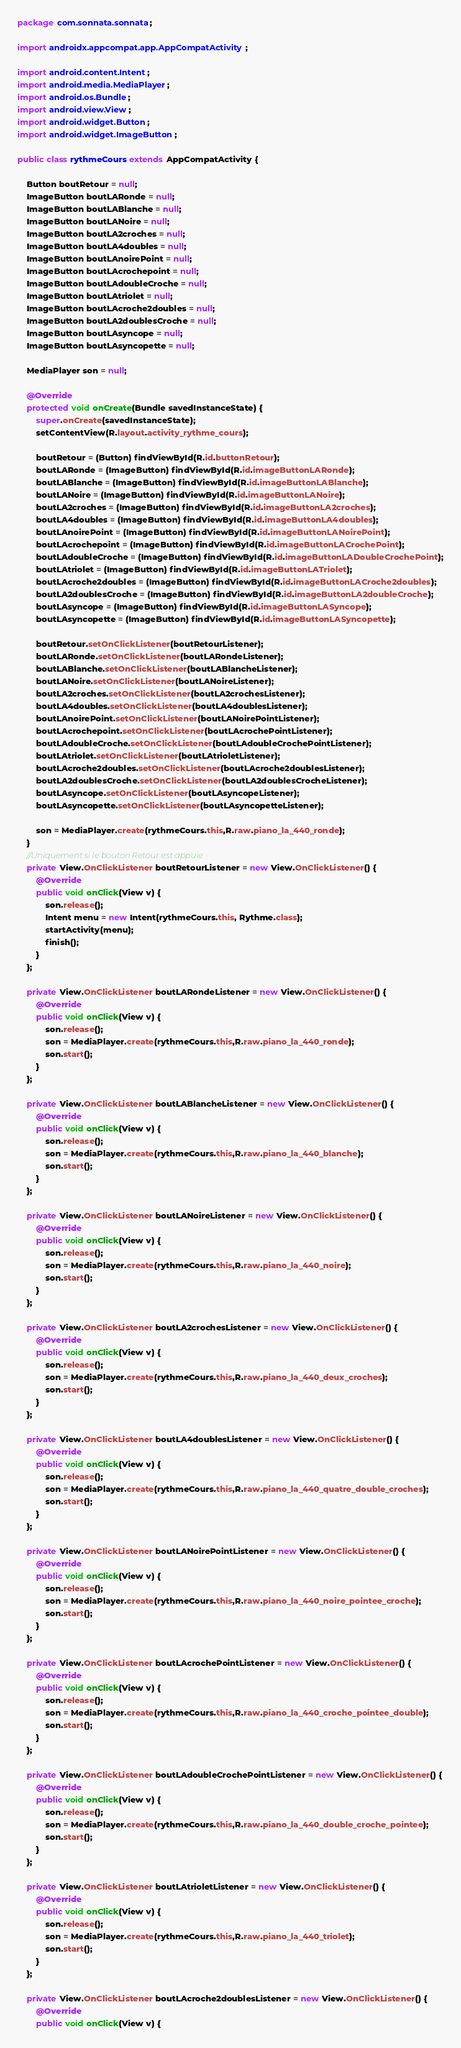<code> <loc_0><loc_0><loc_500><loc_500><_Java_>package com.sonnata.sonnata;

import androidx.appcompat.app.AppCompatActivity;

import android.content.Intent;
import android.media.MediaPlayer;
import android.os.Bundle;
import android.view.View;
import android.widget.Button;
import android.widget.ImageButton;

public class rythmeCours extends AppCompatActivity {

    Button boutRetour = null;
    ImageButton boutLARonde = null;
    ImageButton boutLABlanche = null;
    ImageButton boutLANoire = null;
    ImageButton boutLA2croches = null;
    ImageButton boutLA4doubles = null;
    ImageButton boutLAnoirePoint = null;
    ImageButton boutLAcrochepoint = null;
    ImageButton boutLAdoubleCroche = null;
    ImageButton boutLAtriolet = null;
    ImageButton boutLAcroche2doubles = null;
    ImageButton boutLA2doublesCroche = null;
    ImageButton boutLAsyncope = null;
    ImageButton boutLAsyncopette = null;

    MediaPlayer son = null;

    @Override
    protected void onCreate(Bundle savedInstanceState) {
        super.onCreate(savedInstanceState);
        setContentView(R.layout.activity_rythme_cours);

        boutRetour = (Button) findViewById(R.id.buttonRetour);
        boutLARonde = (ImageButton) findViewById(R.id.imageButtonLARonde);
        boutLABlanche = (ImageButton) findViewById(R.id.imageButtonLABlanche);
        boutLANoire = (ImageButton) findViewById(R.id.imageButtonLANoire);
        boutLA2croches = (ImageButton) findViewById(R.id.imageButtonLA2croches);
        boutLA4doubles = (ImageButton) findViewById(R.id.imageButtonLA4doubles);
        boutLAnoirePoint = (ImageButton) findViewById(R.id.imageButtonLANoirePoint);
        boutLAcrochepoint = (ImageButton) findViewById(R.id.imageButtonLACrochePoint);
        boutLAdoubleCroche = (ImageButton) findViewById(R.id.imageButtonLADoubleCrochePoint);
        boutLAtriolet = (ImageButton) findViewById(R.id.imageButtonLATriolet);
        boutLAcroche2doubles = (ImageButton) findViewById(R.id.imageButtonLACroche2doubles);
        boutLA2doublesCroche = (ImageButton) findViewById(R.id.imageButtonLA2doubleCroche);
        boutLAsyncope = (ImageButton) findViewById(R.id.imageButtonLASyncope);
        boutLAsyncopette = (ImageButton) findViewById(R.id.imageButtonLASyncopette);

        boutRetour.setOnClickListener(boutRetourListener);
        boutLARonde.setOnClickListener(boutLARondeListener);
        boutLABlanche.setOnClickListener(boutLABlancheListener);
        boutLANoire.setOnClickListener(boutLANoireListener);
        boutLA2croches.setOnClickListener(boutLA2crochesListener);
        boutLA4doubles.setOnClickListener(boutLA4doublesListener);
        boutLAnoirePoint.setOnClickListener(boutLANoirePointListener);
        boutLAcrochepoint.setOnClickListener(boutLAcrochePointListener);
        boutLAdoubleCroche.setOnClickListener(boutLAdoubleCrochePointListener);
        boutLAtriolet.setOnClickListener(boutLAtrioletListener);
        boutLAcroche2doubles.setOnClickListener(boutLAcroche2doublesListener);
        boutLA2doublesCroche.setOnClickListener(boutLA2doublesCrocheListener);
        boutLAsyncope.setOnClickListener(boutLAsyncopeListener);
        boutLAsyncopette.setOnClickListener(boutLAsyncopetteListener);

        son = MediaPlayer.create(rythmeCours.this,R.raw.piano_la_440_ronde);
    }
    //Uniquement si le bouton Retour est appuie
    private View.OnClickListener boutRetourListener = new View.OnClickListener() {
        @Override
        public void onClick(View v) {
            son.release();
            Intent menu = new Intent(rythmeCours.this, Rythme.class);
            startActivity(menu);
            finish();
        }
    };

    private View.OnClickListener boutLARondeListener = new View.OnClickListener() {
        @Override
        public void onClick(View v) {
            son.release();
            son = MediaPlayer.create(rythmeCours.this,R.raw.piano_la_440_ronde);
            son.start();
        }
    };

    private View.OnClickListener boutLABlancheListener = new View.OnClickListener() {
        @Override
        public void onClick(View v) {
            son.release();
            son = MediaPlayer.create(rythmeCours.this,R.raw.piano_la_440_blanche);
            son.start();
        }
    };

    private View.OnClickListener boutLANoireListener = new View.OnClickListener() {
        @Override
        public void onClick(View v) {
            son.release();
            son = MediaPlayer.create(rythmeCours.this,R.raw.piano_la_440_noire);
            son.start();
        }
    };

    private View.OnClickListener boutLA2crochesListener = new View.OnClickListener() {
        @Override
        public void onClick(View v) {
            son.release();
            son = MediaPlayer.create(rythmeCours.this,R.raw.piano_la_440_deux_croches);
            son.start();
        }
    };

    private View.OnClickListener boutLA4doublesListener = new View.OnClickListener() {
        @Override
        public void onClick(View v) {
            son.release();
            son = MediaPlayer.create(rythmeCours.this,R.raw.piano_la_440_quatre_double_croches);
            son.start();
        }
    };

    private View.OnClickListener boutLANoirePointListener = new View.OnClickListener() {
        @Override
        public void onClick(View v) {
            son.release();
            son = MediaPlayer.create(rythmeCours.this,R.raw.piano_la_440_noire_pointee_croche);
            son.start();
        }
    };

    private View.OnClickListener boutLAcrochePointListener = new View.OnClickListener() {
        @Override
        public void onClick(View v) {
            son.release();
            son = MediaPlayer.create(rythmeCours.this,R.raw.piano_la_440_croche_pointee_double);
            son.start();
        }
    };

    private View.OnClickListener boutLAdoubleCrochePointListener = new View.OnClickListener() {
        @Override
        public void onClick(View v) {
            son.release();
            son = MediaPlayer.create(rythmeCours.this,R.raw.piano_la_440_double_croche_pointee);
            son.start();
        }
    };

    private View.OnClickListener boutLAtrioletListener = new View.OnClickListener() {
        @Override
        public void onClick(View v) {
            son.release();
            son = MediaPlayer.create(rythmeCours.this,R.raw.piano_la_440_triolet);
            son.start();
        }
    };

    private View.OnClickListener boutLAcroche2doublesListener = new View.OnClickListener() {
        @Override
        public void onClick(View v) {</code> 